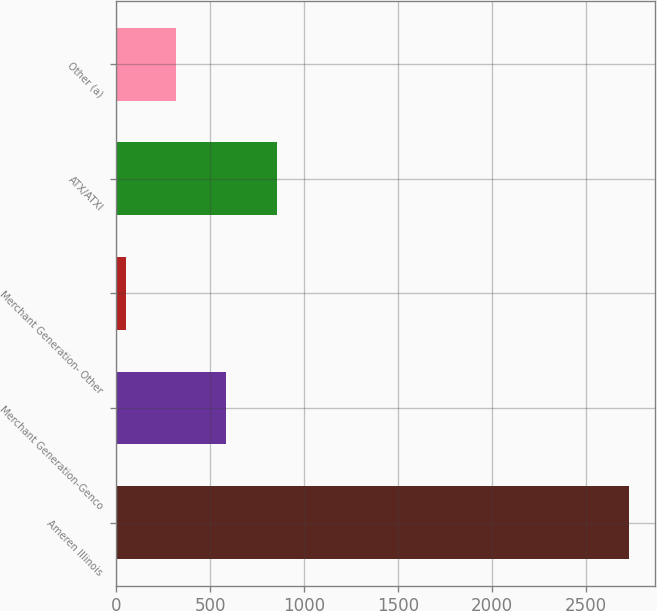Convert chart to OTSL. <chart><loc_0><loc_0><loc_500><loc_500><bar_chart><fcel>Ameren Illinois<fcel>Merchant Generation-Genco<fcel>Merchant Generation- Other<fcel>ATX/ATXI<fcel>Other (a)<nl><fcel>2730<fcel>586<fcel>50<fcel>854<fcel>318<nl></chart> 